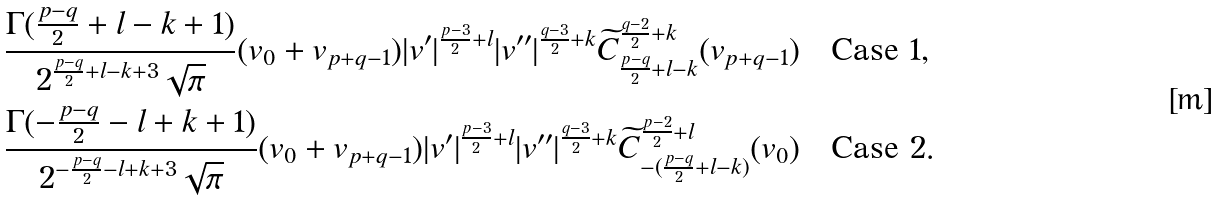<formula> <loc_0><loc_0><loc_500><loc_500>& \frac { \Gamma ( \frac { p - q } 2 + l - k + 1 ) } { 2 ^ { \frac { p - q } 2 + l - k + 3 } \sqrt { \pi } } ( v _ { 0 } + v _ { p + q - 1 } ) | v ^ { \prime } | ^ { \frac { p - 3 } 2 + l } | v ^ { \prime \prime } | ^ { \frac { q - 3 } 2 + k } \widetilde { C } _ { \frac { p - q } 2 + l - k } ^ { \frac { q - 2 } 2 + k } ( v _ { p + q - 1 } ) \quad \text {Case 1,} \\ & \frac { \Gamma ( - \frac { p - q } 2 - l + k + 1 ) } { 2 ^ { - \frac { p - q } 2 - l + k + 3 } \sqrt { \pi } } ( v _ { 0 } + v _ { p + q - 1 } ) | v ^ { \prime } | ^ { \frac { p - 3 } { 2 } + l } | v ^ { \prime \prime } | ^ { \frac { q - 3 } { 2 } + k } \widetilde { C } _ { - ( \frac { p - q } 2 + l - k ) } ^ { \frac { p - 2 } 2 + l } ( v _ { 0 } ) \quad \text {Case 2} .</formula> 